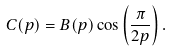Convert formula to latex. <formula><loc_0><loc_0><loc_500><loc_500>C ( p ) = B ( p ) \cos \left ( \frac { \pi } { 2 p } \right ) .</formula> 